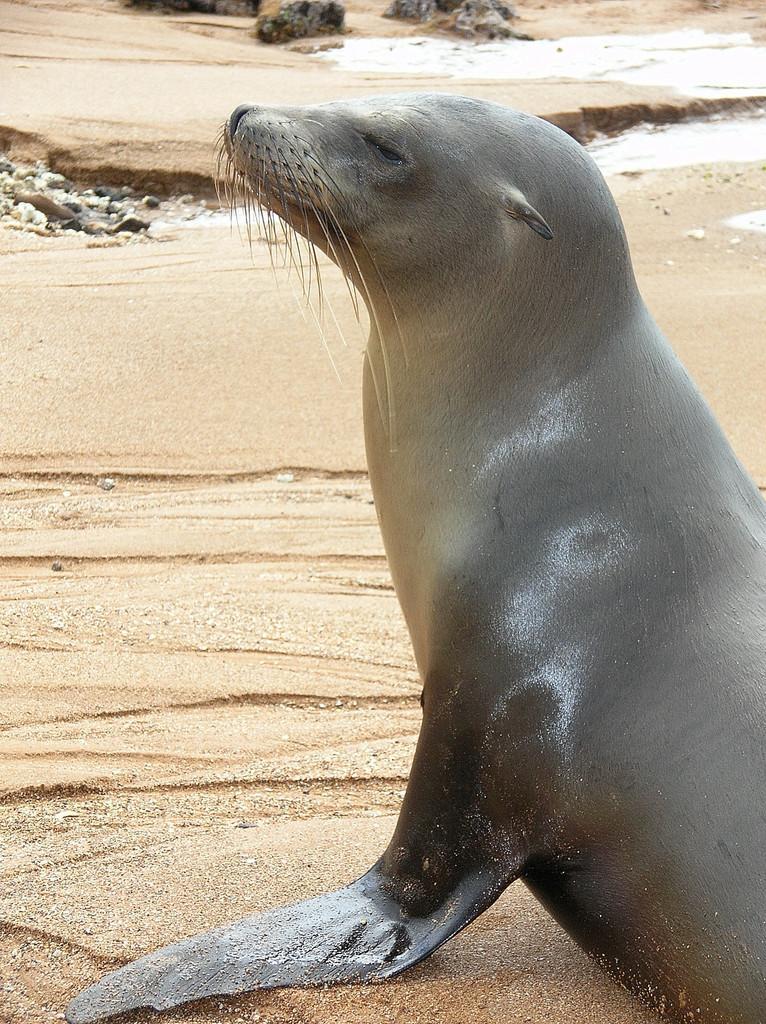Can you describe this image briefly? In this picture there is a seal. At the bottom there is sand and there are stones and there is water. 